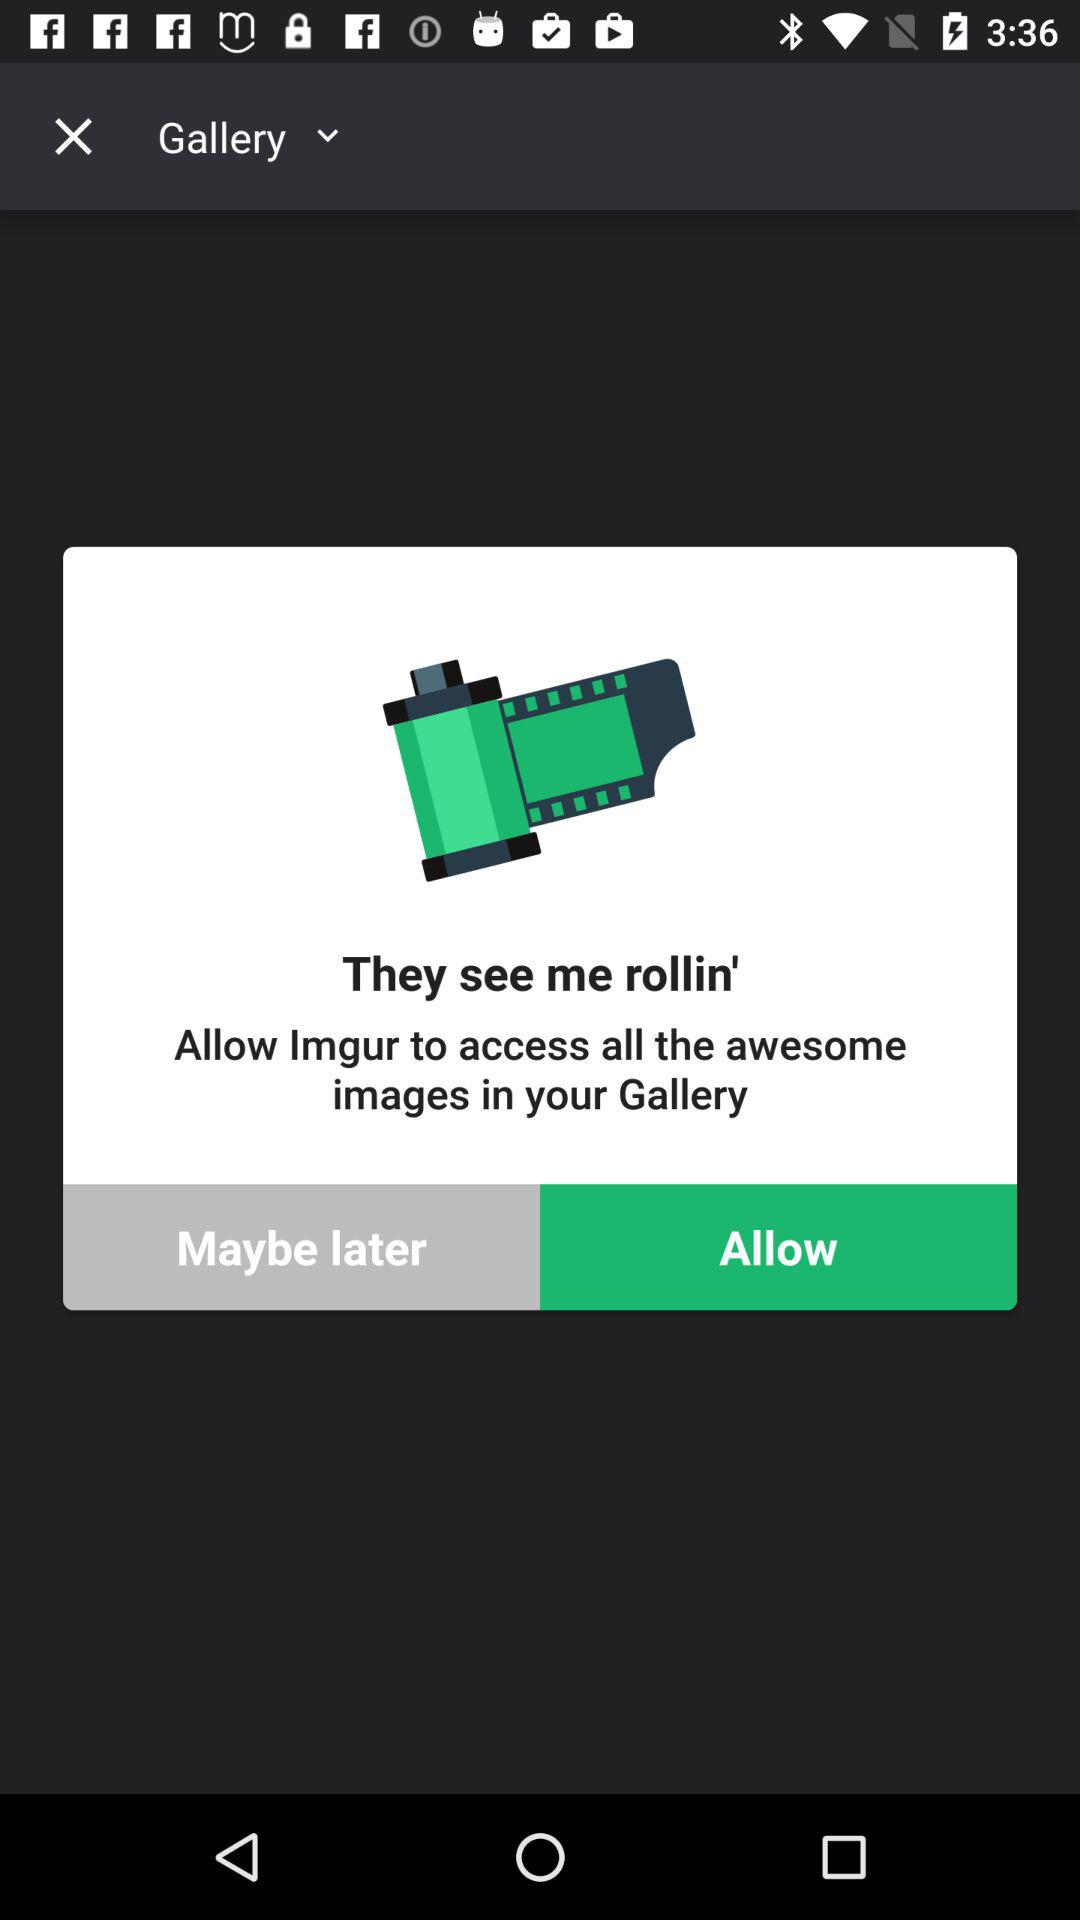What application needs access to all the awesome images in the gallery? The application that needs access is "Imgur". 